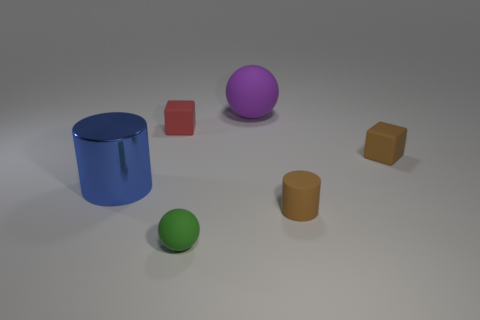Add 1 brown cylinders. How many objects exist? 7 Subtract all cylinders. How many objects are left? 4 Subtract 0 yellow cubes. How many objects are left? 6 Subtract all brown rubber cubes. Subtract all brown cylinders. How many objects are left? 4 Add 6 red matte objects. How many red matte objects are left? 7 Add 5 brown cylinders. How many brown cylinders exist? 6 